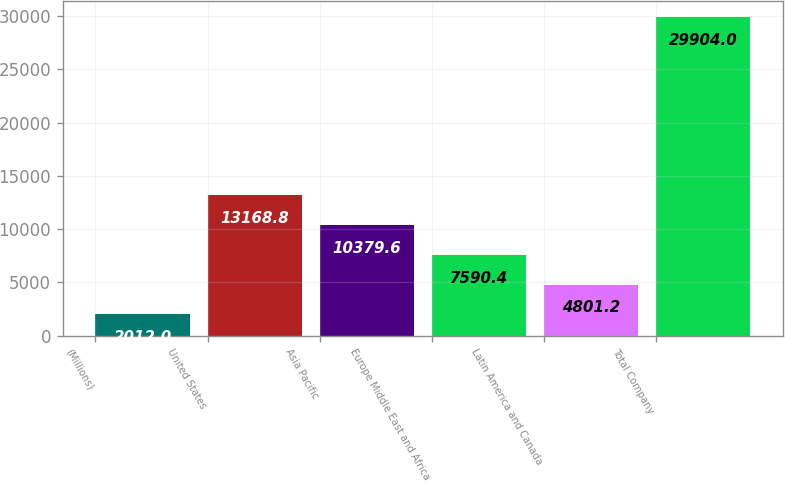Convert chart to OTSL. <chart><loc_0><loc_0><loc_500><loc_500><bar_chart><fcel>(Millions)<fcel>United States<fcel>Asia Pacific<fcel>Europe Middle East and Africa<fcel>Latin America and Canada<fcel>Total Company<nl><fcel>2012<fcel>13168.8<fcel>10379.6<fcel>7590.4<fcel>4801.2<fcel>29904<nl></chart> 